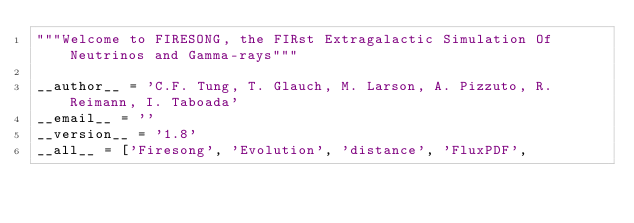<code> <loc_0><loc_0><loc_500><loc_500><_Python_>"""Welcome to FIRESONG, the FIRst Extragalactic Simulation Of Neutrinos and Gamma-rays"""

__author__ = 'C.F. Tung, T. Glauch, M. Larson, A. Pizzuto, R. Reimann, I. Taboada'
__email__ = ''
__version__ = '1.8'
__all__ = ['Firesong', 'Evolution', 'distance', 'FluxPDF', </code> 